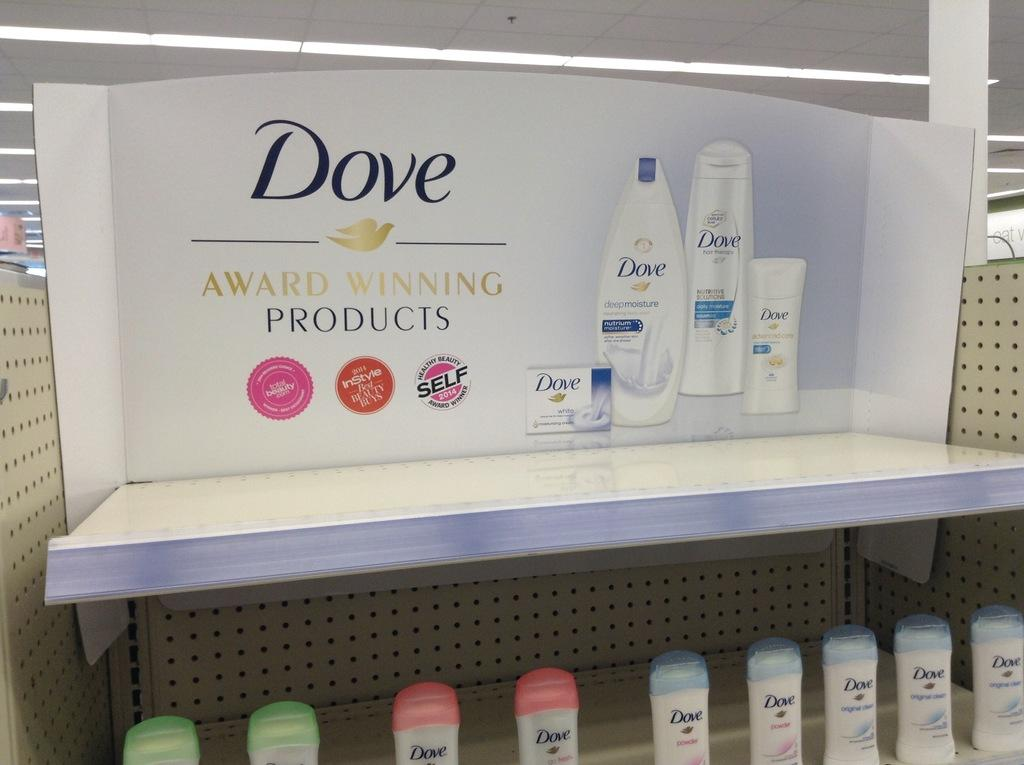<image>
Relay a brief, clear account of the picture shown. The stand inside the door is for Dove products 